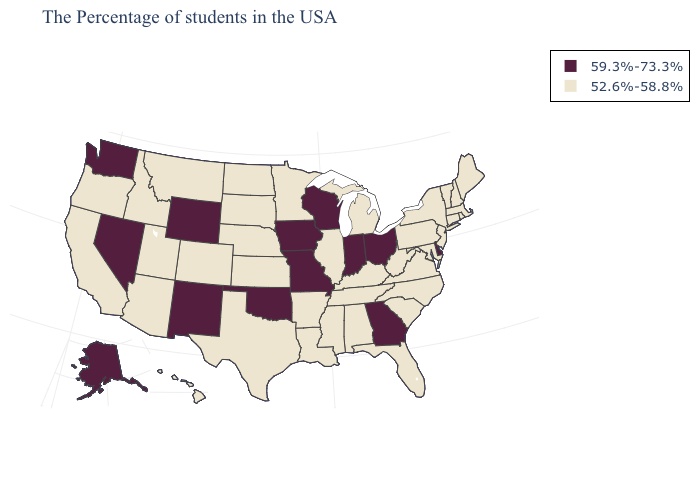Does the first symbol in the legend represent the smallest category?
Keep it brief. No. What is the value of Pennsylvania?
Quick response, please. 52.6%-58.8%. Name the states that have a value in the range 59.3%-73.3%?
Quick response, please. Delaware, Ohio, Georgia, Indiana, Wisconsin, Missouri, Iowa, Oklahoma, Wyoming, New Mexico, Nevada, Washington, Alaska. Name the states that have a value in the range 52.6%-58.8%?
Be succinct. Maine, Massachusetts, Rhode Island, New Hampshire, Vermont, Connecticut, New York, New Jersey, Maryland, Pennsylvania, Virginia, North Carolina, South Carolina, West Virginia, Florida, Michigan, Kentucky, Alabama, Tennessee, Illinois, Mississippi, Louisiana, Arkansas, Minnesota, Kansas, Nebraska, Texas, South Dakota, North Dakota, Colorado, Utah, Montana, Arizona, Idaho, California, Oregon, Hawaii. Name the states that have a value in the range 52.6%-58.8%?
Quick response, please. Maine, Massachusetts, Rhode Island, New Hampshire, Vermont, Connecticut, New York, New Jersey, Maryland, Pennsylvania, Virginia, North Carolina, South Carolina, West Virginia, Florida, Michigan, Kentucky, Alabama, Tennessee, Illinois, Mississippi, Louisiana, Arkansas, Minnesota, Kansas, Nebraska, Texas, South Dakota, North Dakota, Colorado, Utah, Montana, Arizona, Idaho, California, Oregon, Hawaii. What is the highest value in states that border Maryland?
Short answer required. 59.3%-73.3%. Name the states that have a value in the range 59.3%-73.3%?
Quick response, please. Delaware, Ohio, Georgia, Indiana, Wisconsin, Missouri, Iowa, Oklahoma, Wyoming, New Mexico, Nevada, Washington, Alaska. Among the states that border Indiana , does Ohio have the lowest value?
Write a very short answer. No. Name the states that have a value in the range 59.3%-73.3%?
Give a very brief answer. Delaware, Ohio, Georgia, Indiana, Wisconsin, Missouri, Iowa, Oklahoma, Wyoming, New Mexico, Nevada, Washington, Alaska. What is the value of Minnesota?
Give a very brief answer. 52.6%-58.8%. Does Oregon have a lower value than New Mexico?
Write a very short answer. Yes. Name the states that have a value in the range 59.3%-73.3%?
Keep it brief. Delaware, Ohio, Georgia, Indiana, Wisconsin, Missouri, Iowa, Oklahoma, Wyoming, New Mexico, Nevada, Washington, Alaska. Does Louisiana have the highest value in the South?
Answer briefly. No. Name the states that have a value in the range 52.6%-58.8%?
Short answer required. Maine, Massachusetts, Rhode Island, New Hampshire, Vermont, Connecticut, New York, New Jersey, Maryland, Pennsylvania, Virginia, North Carolina, South Carolina, West Virginia, Florida, Michigan, Kentucky, Alabama, Tennessee, Illinois, Mississippi, Louisiana, Arkansas, Minnesota, Kansas, Nebraska, Texas, South Dakota, North Dakota, Colorado, Utah, Montana, Arizona, Idaho, California, Oregon, Hawaii. What is the value of Florida?
Quick response, please. 52.6%-58.8%. 